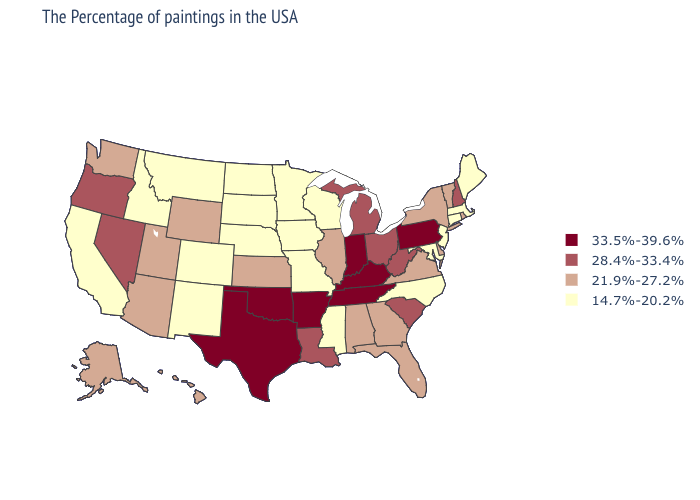Does Nevada have a higher value than Kentucky?
Keep it brief. No. Name the states that have a value in the range 28.4%-33.4%?
Keep it brief. New Hampshire, South Carolina, West Virginia, Ohio, Michigan, Louisiana, Nevada, Oregon. Name the states that have a value in the range 33.5%-39.6%?
Keep it brief. Pennsylvania, Kentucky, Indiana, Tennessee, Arkansas, Oklahoma, Texas. Among the states that border Wyoming , which have the lowest value?
Quick response, please. Nebraska, South Dakota, Colorado, Montana, Idaho. Among the states that border South Dakota , which have the lowest value?
Concise answer only. Minnesota, Iowa, Nebraska, North Dakota, Montana. Does North Carolina have the highest value in the USA?
Concise answer only. No. Is the legend a continuous bar?
Keep it brief. No. Among the states that border Louisiana , which have the highest value?
Short answer required. Arkansas, Texas. What is the value of Pennsylvania?
Keep it brief. 33.5%-39.6%. What is the value of Nebraska?
Quick response, please. 14.7%-20.2%. Among the states that border Arkansas , does Mississippi have the lowest value?
Quick response, please. Yes. What is the lowest value in the Northeast?
Concise answer only. 14.7%-20.2%. Among the states that border Pennsylvania , which have the lowest value?
Keep it brief. New Jersey, Maryland. Does Nebraska have the highest value in the MidWest?
Be succinct. No. What is the highest value in the South ?
Concise answer only. 33.5%-39.6%. 